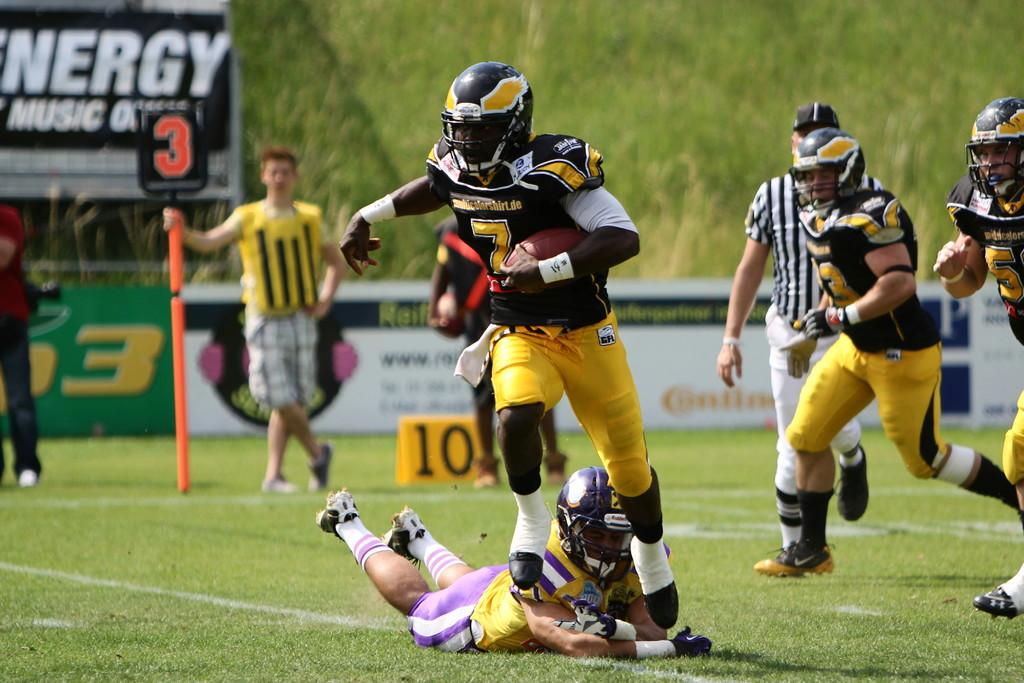What is happening in the image involving the group of people? The people in the image are playing a game. Can you describe any specific clothing worn by someone in the image? There is a person wearing a black and yellow dress in the image. What can be seen in the background of the image? There are boards and trees with green color in the background of the image. What type of liquid is being used in the game by the players? There is no liquid visible in the image, and no indication that a liquid is being used in the game. Can you see a scarecrow in the image? No, there is no scarecrow present in the image. 